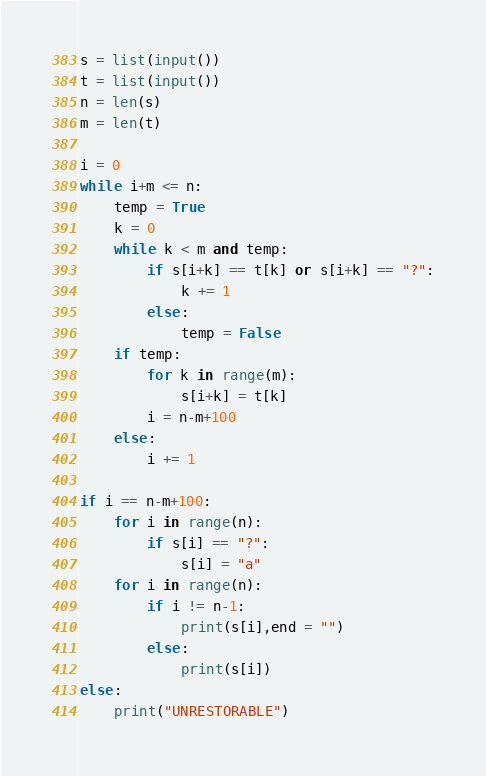<code> <loc_0><loc_0><loc_500><loc_500><_Python_>s = list(input())
t = list(input())
n = len(s)
m = len(t)

i = 0
while i+m <= n:
    temp = True
    k = 0
    while k < m and temp:
        if s[i+k] == t[k] or s[i+k] == "?":
            k += 1
        else:
            temp = False
    if temp:
        for k in range(m):
            s[i+k] = t[k]
        i = n-m+100
    else:
        i += 1

if i == n-m+100:
    for i in range(n):
        if s[i] == "?":
            s[i] = "a"
    for i in range(n):
        if i != n-1:
            print(s[i],end = "")
        else:
            print(s[i])
else:
    print("UNRESTORABLE")</code> 